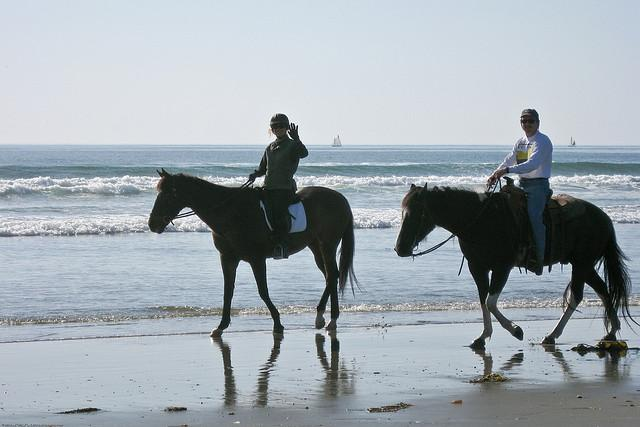Where do the riders here ride their horses? beach 